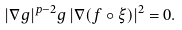<formula> <loc_0><loc_0><loc_500><loc_500>| \nabla g | ^ { p - 2 } g \, | \nabla ( f \circ \xi ) | ^ { 2 } = 0 .</formula> 